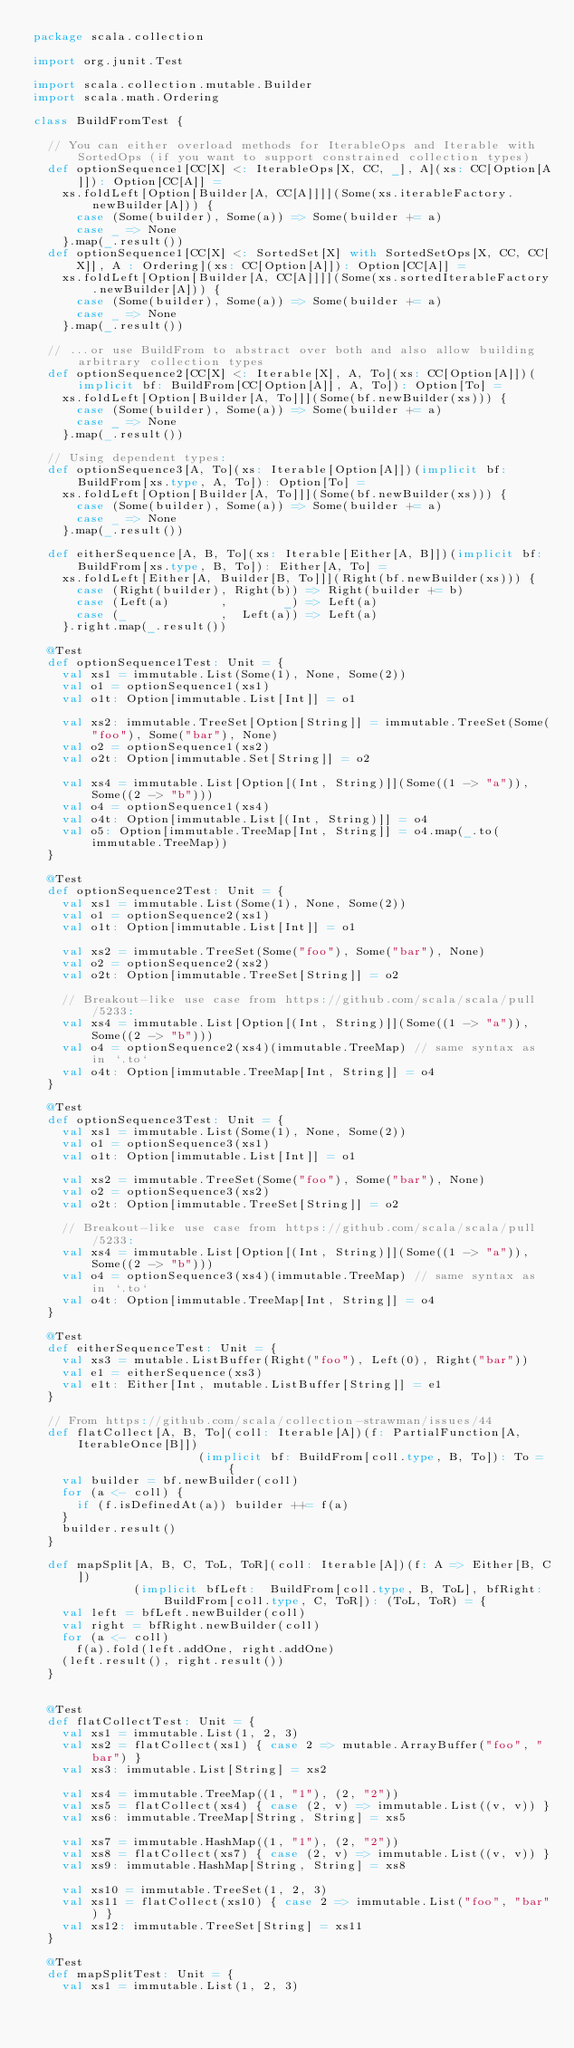<code> <loc_0><loc_0><loc_500><loc_500><_Scala_>package scala.collection

import org.junit.Test

import scala.collection.mutable.Builder
import scala.math.Ordering

class BuildFromTest {

  // You can either overload methods for IterableOps and Iterable with SortedOps (if you want to support constrained collection types)
  def optionSequence1[CC[X] <: IterableOps[X, CC, _], A](xs: CC[Option[A]]): Option[CC[A]] =
    xs.foldLeft[Option[Builder[A, CC[A]]]](Some(xs.iterableFactory.newBuilder[A])) {
      case (Some(builder), Some(a)) => Some(builder += a)
      case _ => None
    }.map(_.result())
  def optionSequence1[CC[X] <: SortedSet[X] with SortedSetOps[X, CC, CC[X]], A : Ordering](xs: CC[Option[A]]): Option[CC[A]] =
    xs.foldLeft[Option[Builder[A, CC[A]]]](Some(xs.sortedIterableFactory.newBuilder[A])) {
      case (Some(builder), Some(a)) => Some(builder += a)
      case _ => None
    }.map(_.result())

  // ...or use BuildFrom to abstract over both and also allow building arbitrary collection types
  def optionSequence2[CC[X] <: Iterable[X], A, To](xs: CC[Option[A]])(implicit bf: BuildFrom[CC[Option[A]], A, To]): Option[To] =
    xs.foldLeft[Option[Builder[A, To]]](Some(bf.newBuilder(xs))) {
      case (Some(builder), Some(a)) => Some(builder += a)
      case _ => None
    }.map(_.result())

  // Using dependent types:
  def optionSequence3[A, To](xs: Iterable[Option[A]])(implicit bf: BuildFrom[xs.type, A, To]): Option[To] =
    xs.foldLeft[Option[Builder[A, To]]](Some(bf.newBuilder(xs))) {
      case (Some(builder), Some(a)) => Some(builder += a)
      case _ => None
    }.map(_.result())

  def eitherSequence[A, B, To](xs: Iterable[Either[A, B]])(implicit bf: BuildFrom[xs.type, B, To]): Either[A, To] =
    xs.foldLeft[Either[A, Builder[B, To]]](Right(bf.newBuilder(xs))) {
      case (Right(builder), Right(b)) => Right(builder += b)
      case (Left(a)       ,        _) => Left(a)
      case (_             ,  Left(a)) => Left(a)
    }.right.map(_.result())

  @Test
  def optionSequence1Test: Unit = {
    val xs1 = immutable.List(Some(1), None, Some(2))
    val o1 = optionSequence1(xs1)
    val o1t: Option[immutable.List[Int]] = o1

    val xs2: immutable.TreeSet[Option[String]] = immutable.TreeSet(Some("foo"), Some("bar"), None)
    val o2 = optionSequence1(xs2)
    val o2t: Option[immutable.Set[String]] = o2

    val xs4 = immutable.List[Option[(Int, String)]](Some((1 -> "a")), Some((2 -> "b")))
    val o4 = optionSequence1(xs4)
    val o4t: Option[immutable.List[(Int, String)]] = o4
    val o5: Option[immutable.TreeMap[Int, String]] = o4.map(_.to(immutable.TreeMap))
  }

  @Test
  def optionSequence2Test: Unit = {
    val xs1 = immutable.List(Some(1), None, Some(2))
    val o1 = optionSequence2(xs1)
    val o1t: Option[immutable.List[Int]] = o1

    val xs2 = immutable.TreeSet(Some("foo"), Some("bar"), None)
    val o2 = optionSequence2(xs2)
    val o2t: Option[immutable.TreeSet[String]] = o2

    // Breakout-like use case from https://github.com/scala/scala/pull/5233:
    val xs4 = immutable.List[Option[(Int, String)]](Some((1 -> "a")), Some((2 -> "b")))
    val o4 = optionSequence2(xs4)(immutable.TreeMap) // same syntax as in `.to`
    val o4t: Option[immutable.TreeMap[Int, String]] = o4
  }

  @Test
  def optionSequence3Test: Unit = {
    val xs1 = immutable.List(Some(1), None, Some(2))
    val o1 = optionSequence3(xs1)
    val o1t: Option[immutable.List[Int]] = o1

    val xs2 = immutable.TreeSet(Some("foo"), Some("bar"), None)
    val o2 = optionSequence3(xs2)
    val o2t: Option[immutable.TreeSet[String]] = o2

    // Breakout-like use case from https://github.com/scala/scala/pull/5233:
    val xs4 = immutable.List[Option[(Int, String)]](Some((1 -> "a")), Some((2 -> "b")))
    val o4 = optionSequence3(xs4)(immutable.TreeMap) // same syntax as in `.to`
    val o4t: Option[immutable.TreeMap[Int, String]] = o4
  }

  @Test
  def eitherSequenceTest: Unit = {
    val xs3 = mutable.ListBuffer(Right("foo"), Left(0), Right("bar"))
    val e1 = eitherSequence(xs3)
    val e1t: Either[Int, mutable.ListBuffer[String]] = e1
  }

  // From https://github.com/scala/collection-strawman/issues/44
  def flatCollect[A, B, To](coll: Iterable[A])(f: PartialFunction[A, IterableOnce[B]])
                       (implicit bf: BuildFrom[coll.type, B, To]): To = {
    val builder = bf.newBuilder(coll)
    for (a <- coll) {
      if (f.isDefinedAt(a)) builder ++= f(a)
    }
    builder.result()
  }

  def mapSplit[A, B, C, ToL, ToR](coll: Iterable[A])(f: A => Either[B, C])
              (implicit bfLeft:  BuildFrom[coll.type, B, ToL], bfRight: BuildFrom[coll.type, C, ToR]): (ToL, ToR) = {
    val left = bfLeft.newBuilder(coll)
    val right = bfRight.newBuilder(coll)
    for (a <- coll)
      f(a).fold(left.addOne, right.addOne)
    (left.result(), right.result())
  }


  @Test
  def flatCollectTest: Unit = {
    val xs1 = immutable.List(1, 2, 3)
    val xs2 = flatCollect(xs1) { case 2 => mutable.ArrayBuffer("foo", "bar") }
    val xs3: immutable.List[String] = xs2

    val xs4 = immutable.TreeMap((1, "1"), (2, "2"))
    val xs5 = flatCollect(xs4) { case (2, v) => immutable.List((v, v)) }
    val xs6: immutable.TreeMap[String, String] = xs5

    val xs7 = immutable.HashMap((1, "1"), (2, "2"))
    val xs8 = flatCollect(xs7) { case (2, v) => immutable.List((v, v)) }
    val xs9: immutable.HashMap[String, String] = xs8

    val xs10 = immutable.TreeSet(1, 2, 3)
    val xs11 = flatCollect(xs10) { case 2 => immutable.List("foo", "bar") }
    val xs12: immutable.TreeSet[String] = xs11
  }

  @Test
  def mapSplitTest: Unit = {
    val xs1 = immutable.List(1, 2, 3)</code> 